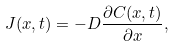<formula> <loc_0><loc_0><loc_500><loc_500>J ( x , t ) = - D \frac { \partial C ( x , t ) } { \partial x } ,</formula> 